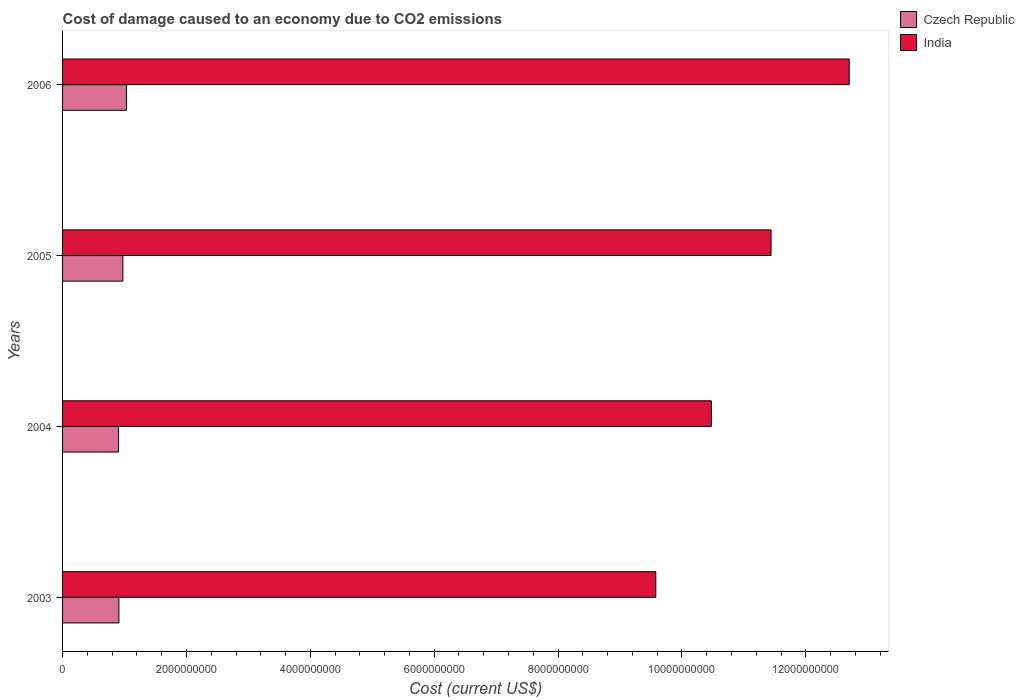How many different coloured bars are there?
Your answer should be very brief. 2. How many groups of bars are there?
Ensure brevity in your answer.  4. How many bars are there on the 3rd tick from the bottom?
Provide a succinct answer. 2. What is the label of the 4th group of bars from the top?
Your response must be concise. 2003. What is the cost of damage caused due to CO2 emissisons in India in 2004?
Your answer should be very brief. 1.05e+1. Across all years, what is the maximum cost of damage caused due to CO2 emissisons in Czech Republic?
Your answer should be compact. 1.03e+09. Across all years, what is the minimum cost of damage caused due to CO2 emissisons in India?
Offer a very short reply. 9.58e+09. What is the total cost of damage caused due to CO2 emissisons in Czech Republic in the graph?
Offer a terse response. 3.82e+09. What is the difference between the cost of damage caused due to CO2 emissisons in Czech Republic in 2003 and that in 2005?
Offer a very short reply. -6.43e+07. What is the difference between the cost of damage caused due to CO2 emissisons in India in 2004 and the cost of damage caused due to CO2 emissisons in Czech Republic in 2003?
Offer a very short reply. 9.56e+09. What is the average cost of damage caused due to CO2 emissisons in India per year?
Ensure brevity in your answer.  1.10e+1. In the year 2004, what is the difference between the cost of damage caused due to CO2 emissisons in Czech Republic and cost of damage caused due to CO2 emissisons in India?
Your answer should be compact. -9.57e+09. What is the ratio of the cost of damage caused due to CO2 emissisons in Czech Republic in 2005 to that in 2006?
Keep it short and to the point. 0.94. Is the cost of damage caused due to CO2 emissisons in India in 2003 less than that in 2005?
Your answer should be very brief. Yes. What is the difference between the highest and the second highest cost of damage caused due to CO2 emissisons in Czech Republic?
Make the answer very short. 5.78e+07. What is the difference between the highest and the lowest cost of damage caused due to CO2 emissisons in Czech Republic?
Offer a terse response. 1.28e+08. What does the 2nd bar from the top in 2005 represents?
Provide a short and direct response. Czech Republic. What does the 2nd bar from the bottom in 2005 represents?
Your answer should be very brief. India. How many bars are there?
Give a very brief answer. 8. Does the graph contain any zero values?
Your answer should be very brief. No. Does the graph contain grids?
Keep it short and to the point. No. Where does the legend appear in the graph?
Make the answer very short. Top right. How many legend labels are there?
Give a very brief answer. 2. How are the legend labels stacked?
Your answer should be very brief. Vertical. What is the title of the graph?
Your answer should be very brief. Cost of damage caused to an economy due to CO2 emissions. Does "Benin" appear as one of the legend labels in the graph?
Offer a very short reply. No. What is the label or title of the X-axis?
Your answer should be very brief. Cost (current US$). What is the label or title of the Y-axis?
Keep it short and to the point. Years. What is the Cost (current US$) of Czech Republic in 2003?
Offer a terse response. 9.09e+08. What is the Cost (current US$) in India in 2003?
Provide a short and direct response. 9.58e+09. What is the Cost (current US$) in Czech Republic in 2004?
Offer a terse response. 9.03e+08. What is the Cost (current US$) in India in 2004?
Make the answer very short. 1.05e+1. What is the Cost (current US$) of Czech Republic in 2005?
Make the answer very short. 9.74e+08. What is the Cost (current US$) of India in 2005?
Keep it short and to the point. 1.14e+1. What is the Cost (current US$) of Czech Republic in 2006?
Offer a terse response. 1.03e+09. What is the Cost (current US$) of India in 2006?
Provide a short and direct response. 1.27e+1. Across all years, what is the maximum Cost (current US$) in Czech Republic?
Offer a very short reply. 1.03e+09. Across all years, what is the maximum Cost (current US$) in India?
Your response must be concise. 1.27e+1. Across all years, what is the minimum Cost (current US$) in Czech Republic?
Offer a very short reply. 9.03e+08. Across all years, what is the minimum Cost (current US$) of India?
Offer a very short reply. 9.58e+09. What is the total Cost (current US$) in Czech Republic in the graph?
Provide a succinct answer. 3.82e+09. What is the total Cost (current US$) of India in the graph?
Offer a terse response. 4.42e+1. What is the difference between the Cost (current US$) of Czech Republic in 2003 and that in 2004?
Offer a very short reply. 5.81e+06. What is the difference between the Cost (current US$) in India in 2003 and that in 2004?
Your answer should be very brief. -8.96e+08. What is the difference between the Cost (current US$) of Czech Republic in 2003 and that in 2005?
Your answer should be very brief. -6.43e+07. What is the difference between the Cost (current US$) of India in 2003 and that in 2005?
Provide a short and direct response. -1.86e+09. What is the difference between the Cost (current US$) of Czech Republic in 2003 and that in 2006?
Give a very brief answer. -1.22e+08. What is the difference between the Cost (current US$) in India in 2003 and that in 2006?
Ensure brevity in your answer.  -3.12e+09. What is the difference between the Cost (current US$) of Czech Republic in 2004 and that in 2005?
Make the answer very short. -7.01e+07. What is the difference between the Cost (current US$) of India in 2004 and that in 2005?
Keep it short and to the point. -9.64e+08. What is the difference between the Cost (current US$) in Czech Republic in 2004 and that in 2006?
Your answer should be very brief. -1.28e+08. What is the difference between the Cost (current US$) of India in 2004 and that in 2006?
Your response must be concise. -2.23e+09. What is the difference between the Cost (current US$) of Czech Republic in 2005 and that in 2006?
Offer a terse response. -5.78e+07. What is the difference between the Cost (current US$) in India in 2005 and that in 2006?
Offer a very short reply. -1.26e+09. What is the difference between the Cost (current US$) in Czech Republic in 2003 and the Cost (current US$) in India in 2004?
Provide a short and direct response. -9.56e+09. What is the difference between the Cost (current US$) of Czech Republic in 2003 and the Cost (current US$) of India in 2005?
Provide a short and direct response. -1.05e+1. What is the difference between the Cost (current US$) of Czech Republic in 2003 and the Cost (current US$) of India in 2006?
Keep it short and to the point. -1.18e+1. What is the difference between the Cost (current US$) in Czech Republic in 2004 and the Cost (current US$) in India in 2005?
Offer a terse response. -1.05e+1. What is the difference between the Cost (current US$) in Czech Republic in 2004 and the Cost (current US$) in India in 2006?
Your response must be concise. -1.18e+1. What is the difference between the Cost (current US$) of Czech Republic in 2005 and the Cost (current US$) of India in 2006?
Give a very brief answer. -1.17e+1. What is the average Cost (current US$) in Czech Republic per year?
Make the answer very short. 9.54e+08. What is the average Cost (current US$) of India per year?
Your answer should be compact. 1.10e+1. In the year 2003, what is the difference between the Cost (current US$) of Czech Republic and Cost (current US$) of India?
Your response must be concise. -8.67e+09. In the year 2004, what is the difference between the Cost (current US$) of Czech Republic and Cost (current US$) of India?
Make the answer very short. -9.57e+09. In the year 2005, what is the difference between the Cost (current US$) in Czech Republic and Cost (current US$) in India?
Your answer should be very brief. -1.05e+1. In the year 2006, what is the difference between the Cost (current US$) of Czech Republic and Cost (current US$) of India?
Your answer should be compact. -1.17e+1. What is the ratio of the Cost (current US$) of Czech Republic in 2003 to that in 2004?
Your answer should be very brief. 1.01. What is the ratio of the Cost (current US$) in India in 2003 to that in 2004?
Your answer should be very brief. 0.91. What is the ratio of the Cost (current US$) in Czech Republic in 2003 to that in 2005?
Provide a short and direct response. 0.93. What is the ratio of the Cost (current US$) in India in 2003 to that in 2005?
Give a very brief answer. 0.84. What is the ratio of the Cost (current US$) of Czech Republic in 2003 to that in 2006?
Offer a terse response. 0.88. What is the ratio of the Cost (current US$) of India in 2003 to that in 2006?
Provide a succinct answer. 0.75. What is the ratio of the Cost (current US$) in Czech Republic in 2004 to that in 2005?
Ensure brevity in your answer.  0.93. What is the ratio of the Cost (current US$) in India in 2004 to that in 2005?
Ensure brevity in your answer.  0.92. What is the ratio of the Cost (current US$) of Czech Republic in 2004 to that in 2006?
Your response must be concise. 0.88. What is the ratio of the Cost (current US$) of India in 2004 to that in 2006?
Offer a very short reply. 0.82. What is the ratio of the Cost (current US$) in Czech Republic in 2005 to that in 2006?
Keep it short and to the point. 0.94. What is the ratio of the Cost (current US$) of India in 2005 to that in 2006?
Provide a short and direct response. 0.9. What is the difference between the highest and the second highest Cost (current US$) of Czech Republic?
Your answer should be very brief. 5.78e+07. What is the difference between the highest and the second highest Cost (current US$) of India?
Your answer should be compact. 1.26e+09. What is the difference between the highest and the lowest Cost (current US$) in Czech Republic?
Your answer should be very brief. 1.28e+08. What is the difference between the highest and the lowest Cost (current US$) in India?
Give a very brief answer. 3.12e+09. 